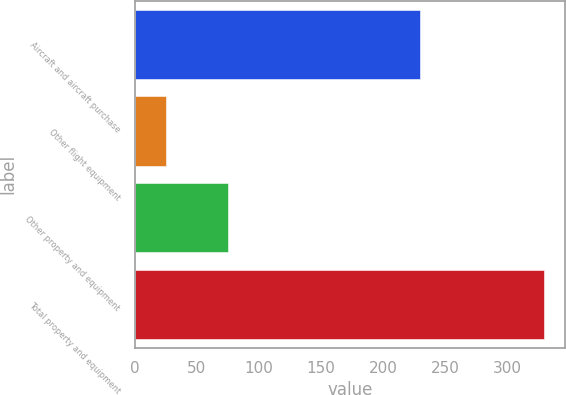<chart> <loc_0><loc_0><loc_500><loc_500><bar_chart><fcel>Aircraft and aircraft purchase<fcel>Other flight equipment<fcel>Other property and equipment<fcel>Total property and equipment<nl><fcel>230<fcel>25<fcel>75<fcel>330<nl></chart> 